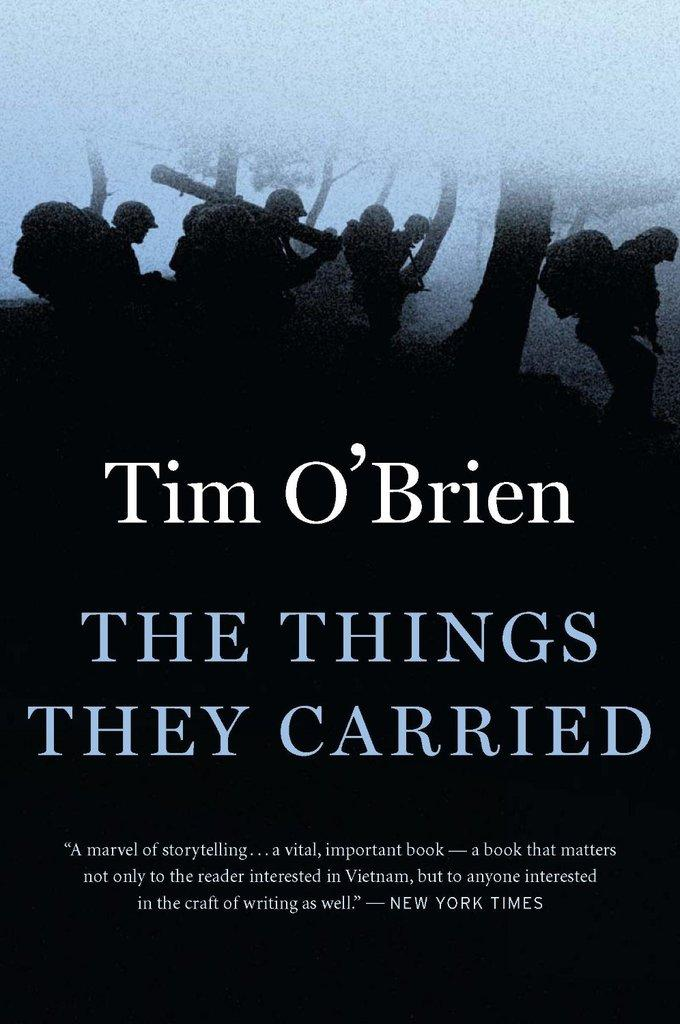<image>
Give a short and clear explanation of the subsequent image. The things they carried book that was featured in new york times 